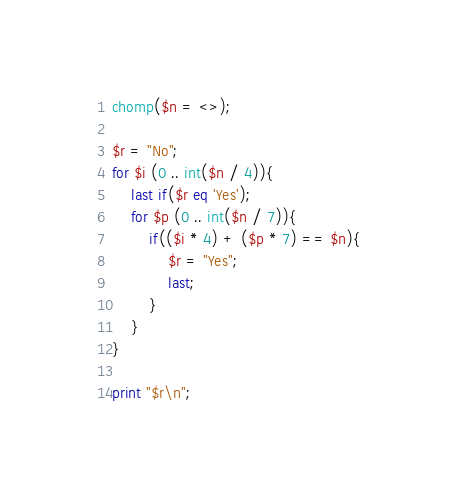<code> <loc_0><loc_0><loc_500><loc_500><_Perl_>chomp($n = <>);

$r = "No";
for $i (0 .. int($n / 4)){
	last if($r eq 'Yes');
	for $p (0 .. int($n / 7)){
		if(($i * 4) + ($p * 7) == $n){
			$r = "Yes";
			last;
		}
	}
}

print "$r\n";
</code> 